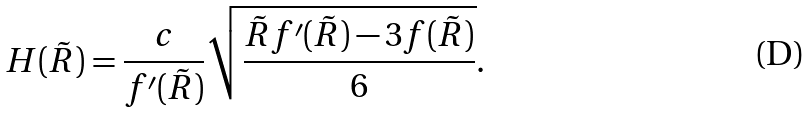<formula> <loc_0><loc_0><loc_500><loc_500>H ( \tilde { R } ) = \frac { c } { f ^ { \prime } ( \tilde { R } ) } \sqrt { \frac { \tilde { R } f ^ { \prime } ( \tilde { R } ) - 3 f ( \tilde { R } ) } { 6 } } .</formula> 